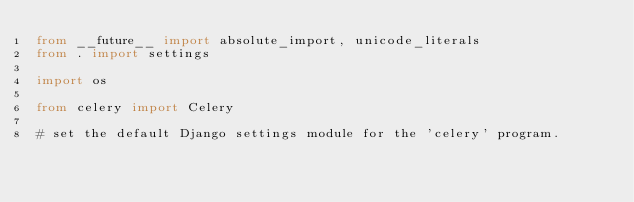Convert code to text. <code><loc_0><loc_0><loc_500><loc_500><_Python_>from __future__ import absolute_import, unicode_literals
from . import settings

import os

from celery import Celery

# set the default Django settings module for the 'celery' program.</code> 